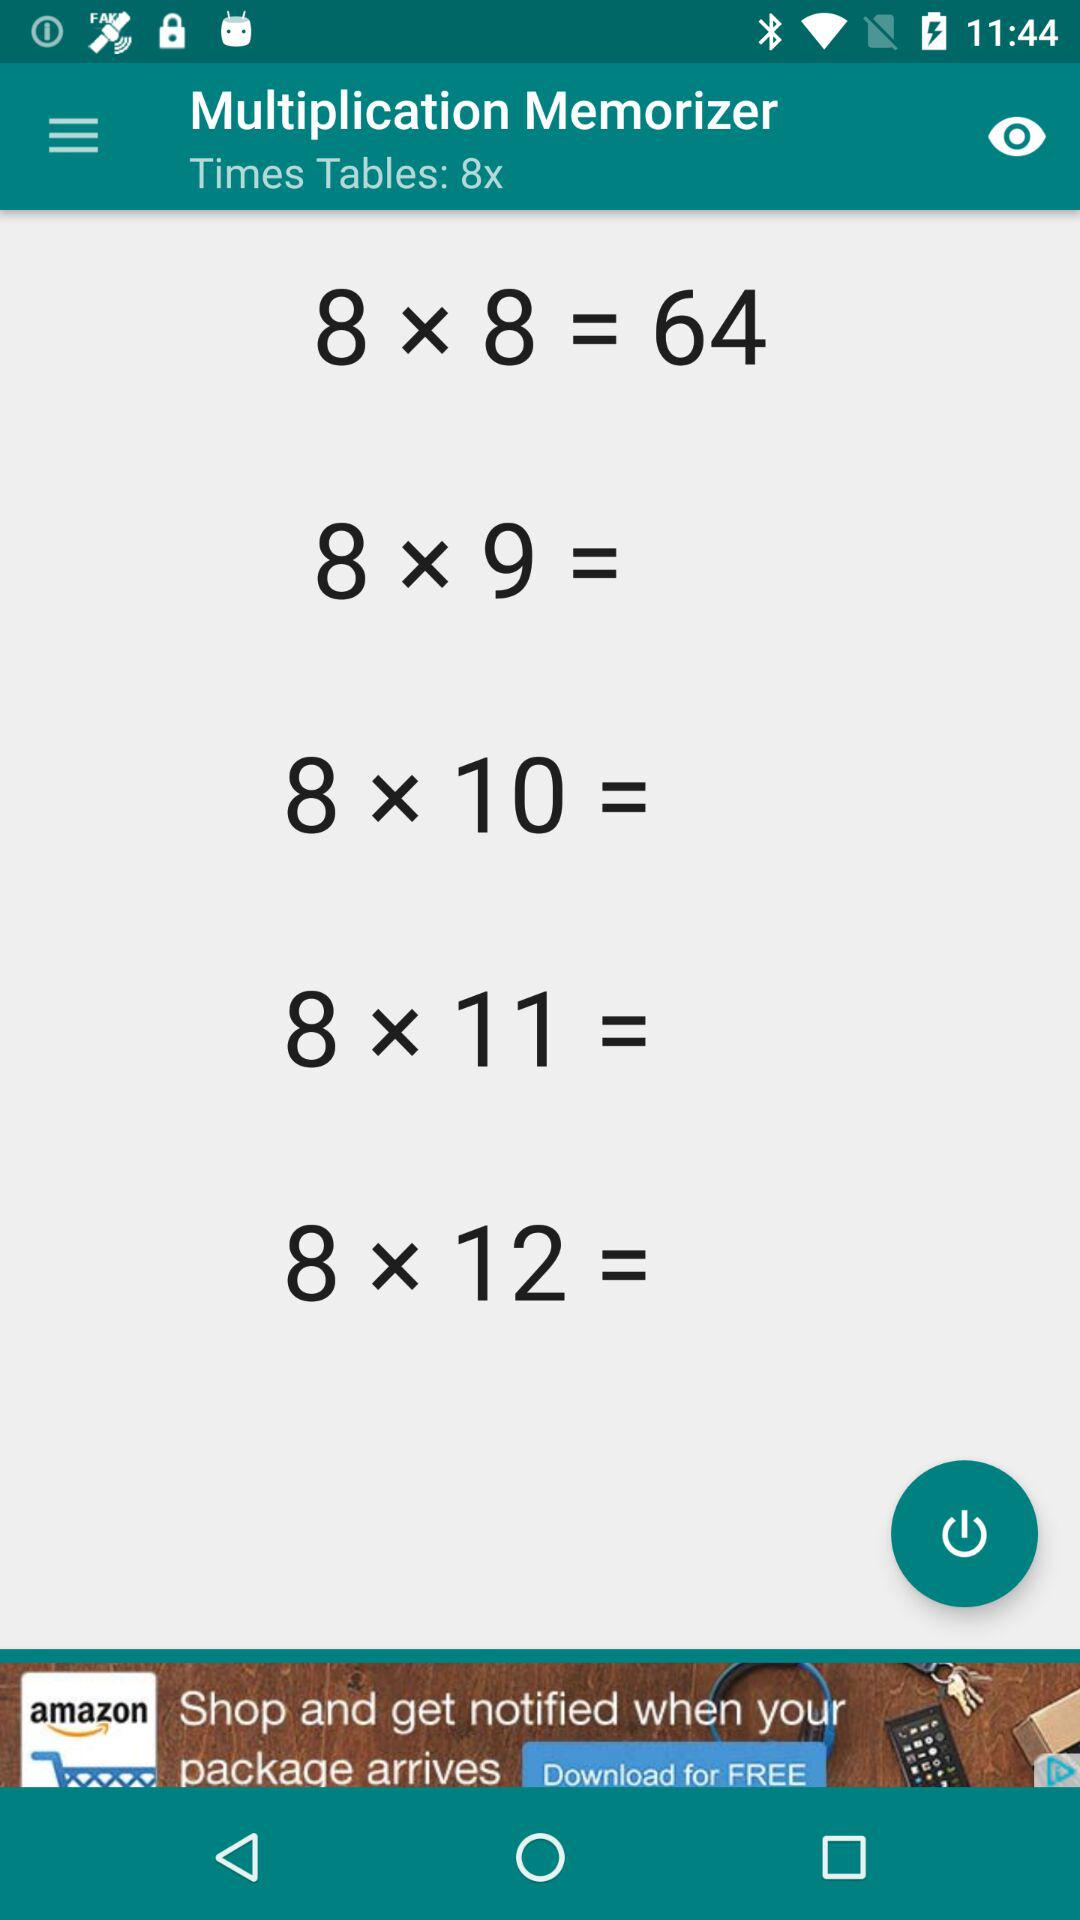What's the current "Times Tables"? The current "Times Tables" is 8x. 